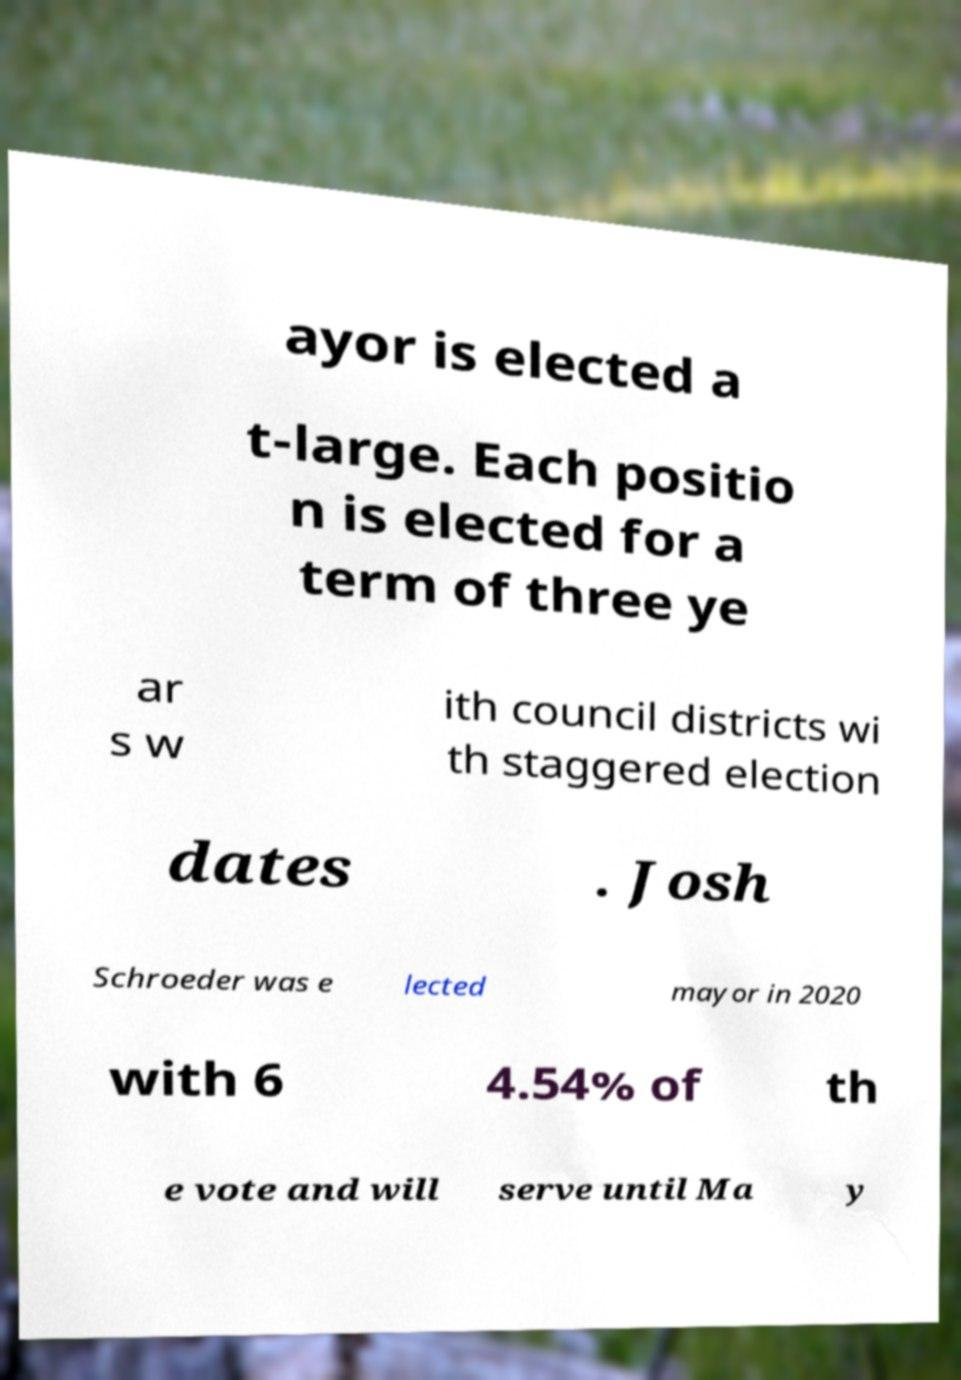What messages or text are displayed in this image? I need them in a readable, typed format. ayor is elected a t-large. Each positio n is elected for a term of three ye ar s w ith council districts wi th staggered election dates . Josh Schroeder was e lected mayor in 2020 with 6 4.54% of th e vote and will serve until Ma y 